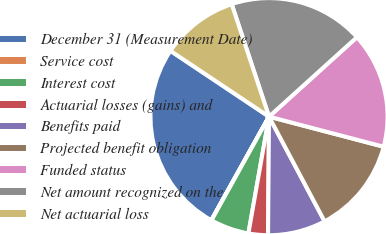Convert chart to OTSL. <chart><loc_0><loc_0><loc_500><loc_500><pie_chart><fcel>December 31 (Measurement Date)<fcel>Service cost<fcel>Interest cost<fcel>Actuarial losses (gains) and<fcel>Benefits paid<fcel>Projected benefit obligation<fcel>Funded status<fcel>Net amount recognized on the<fcel>Net actuarial loss<nl><fcel>26.28%<fcel>0.03%<fcel>5.28%<fcel>2.65%<fcel>7.9%<fcel>13.15%<fcel>15.78%<fcel>18.4%<fcel>10.53%<nl></chart> 